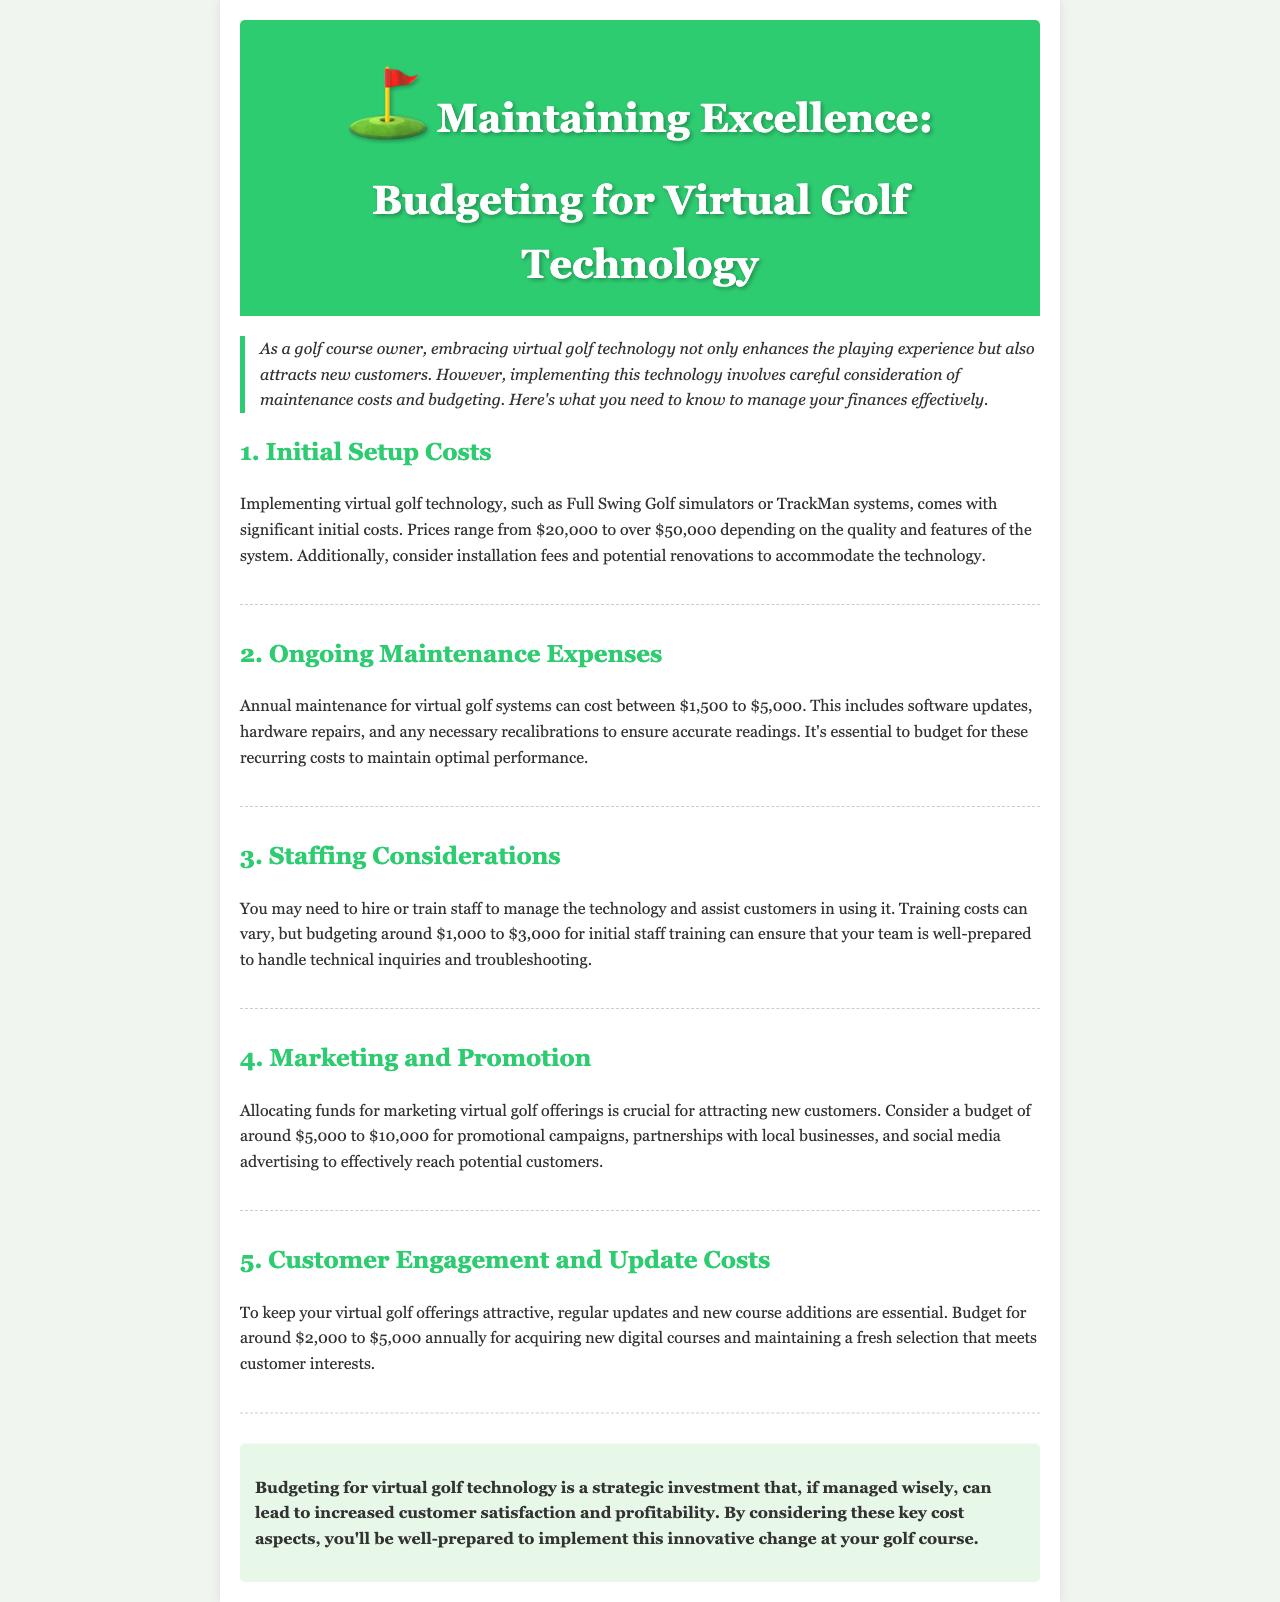What is the initial cost range for virtual golf technology? The initial cost range for virtual golf technology is stated as $20,000 to over $50,000.
Answer: $20,000 to over $50,000 What are the annual maintenance costs? Annual maintenance costs for virtual golf systems range from $1,500 to $5,000.
Answer: $1,500 to $5,000 How much should be budgeted for initial staff training? The recommended budget for initial staff training is around $1,000 to $3,000.
Answer: $1,000 to $3,000 What is the suggested budget for marketing virtual golf offerings? The newsletter suggests a marketing budget of around $5,000 to $10,000.
Answer: $5,000 to $10,000 How much should be allocated annually for customer engagement and updates? For customer engagement and updates, it is suggested to budget around $2,000 to $5,000 annually.
Answer: $2,000 to $5,000 What is a key consideration for budgeting virtual golf technology? A key consideration is to manage maintenance costs effectively to ensure optimal performance.
Answer: Maintenance costs What does the intro suggest is a benefit of implementing virtual golf technology? The intro states that implementing virtual golf technology enhances the playing experience and attracts new customers.
Answer: Enhances playing experience Which technology systems are mentioned in the newsletter? The technology systems mentioned include Full Swing Golf simulators and TrackMan systems.
Answer: Full Swing Golf simulators, TrackMan systems 